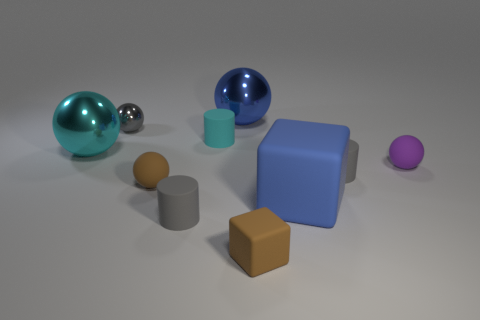Subtract all small cyan cylinders. How many cylinders are left? 2 Subtract 2 spheres. How many spheres are left? 3 Subtract all gray cylinders. How many cylinders are left? 1 Add 5 tiny yellow matte cubes. How many tiny yellow matte cubes exist? 5 Subtract 0 brown cylinders. How many objects are left? 10 Subtract all blocks. How many objects are left? 8 Subtract all cyan balls. Subtract all red cylinders. How many balls are left? 4 Subtract all red spheres. How many gray cylinders are left? 2 Subtract all cyan objects. Subtract all blue spheres. How many objects are left? 7 Add 3 tiny purple matte balls. How many tiny purple matte balls are left? 4 